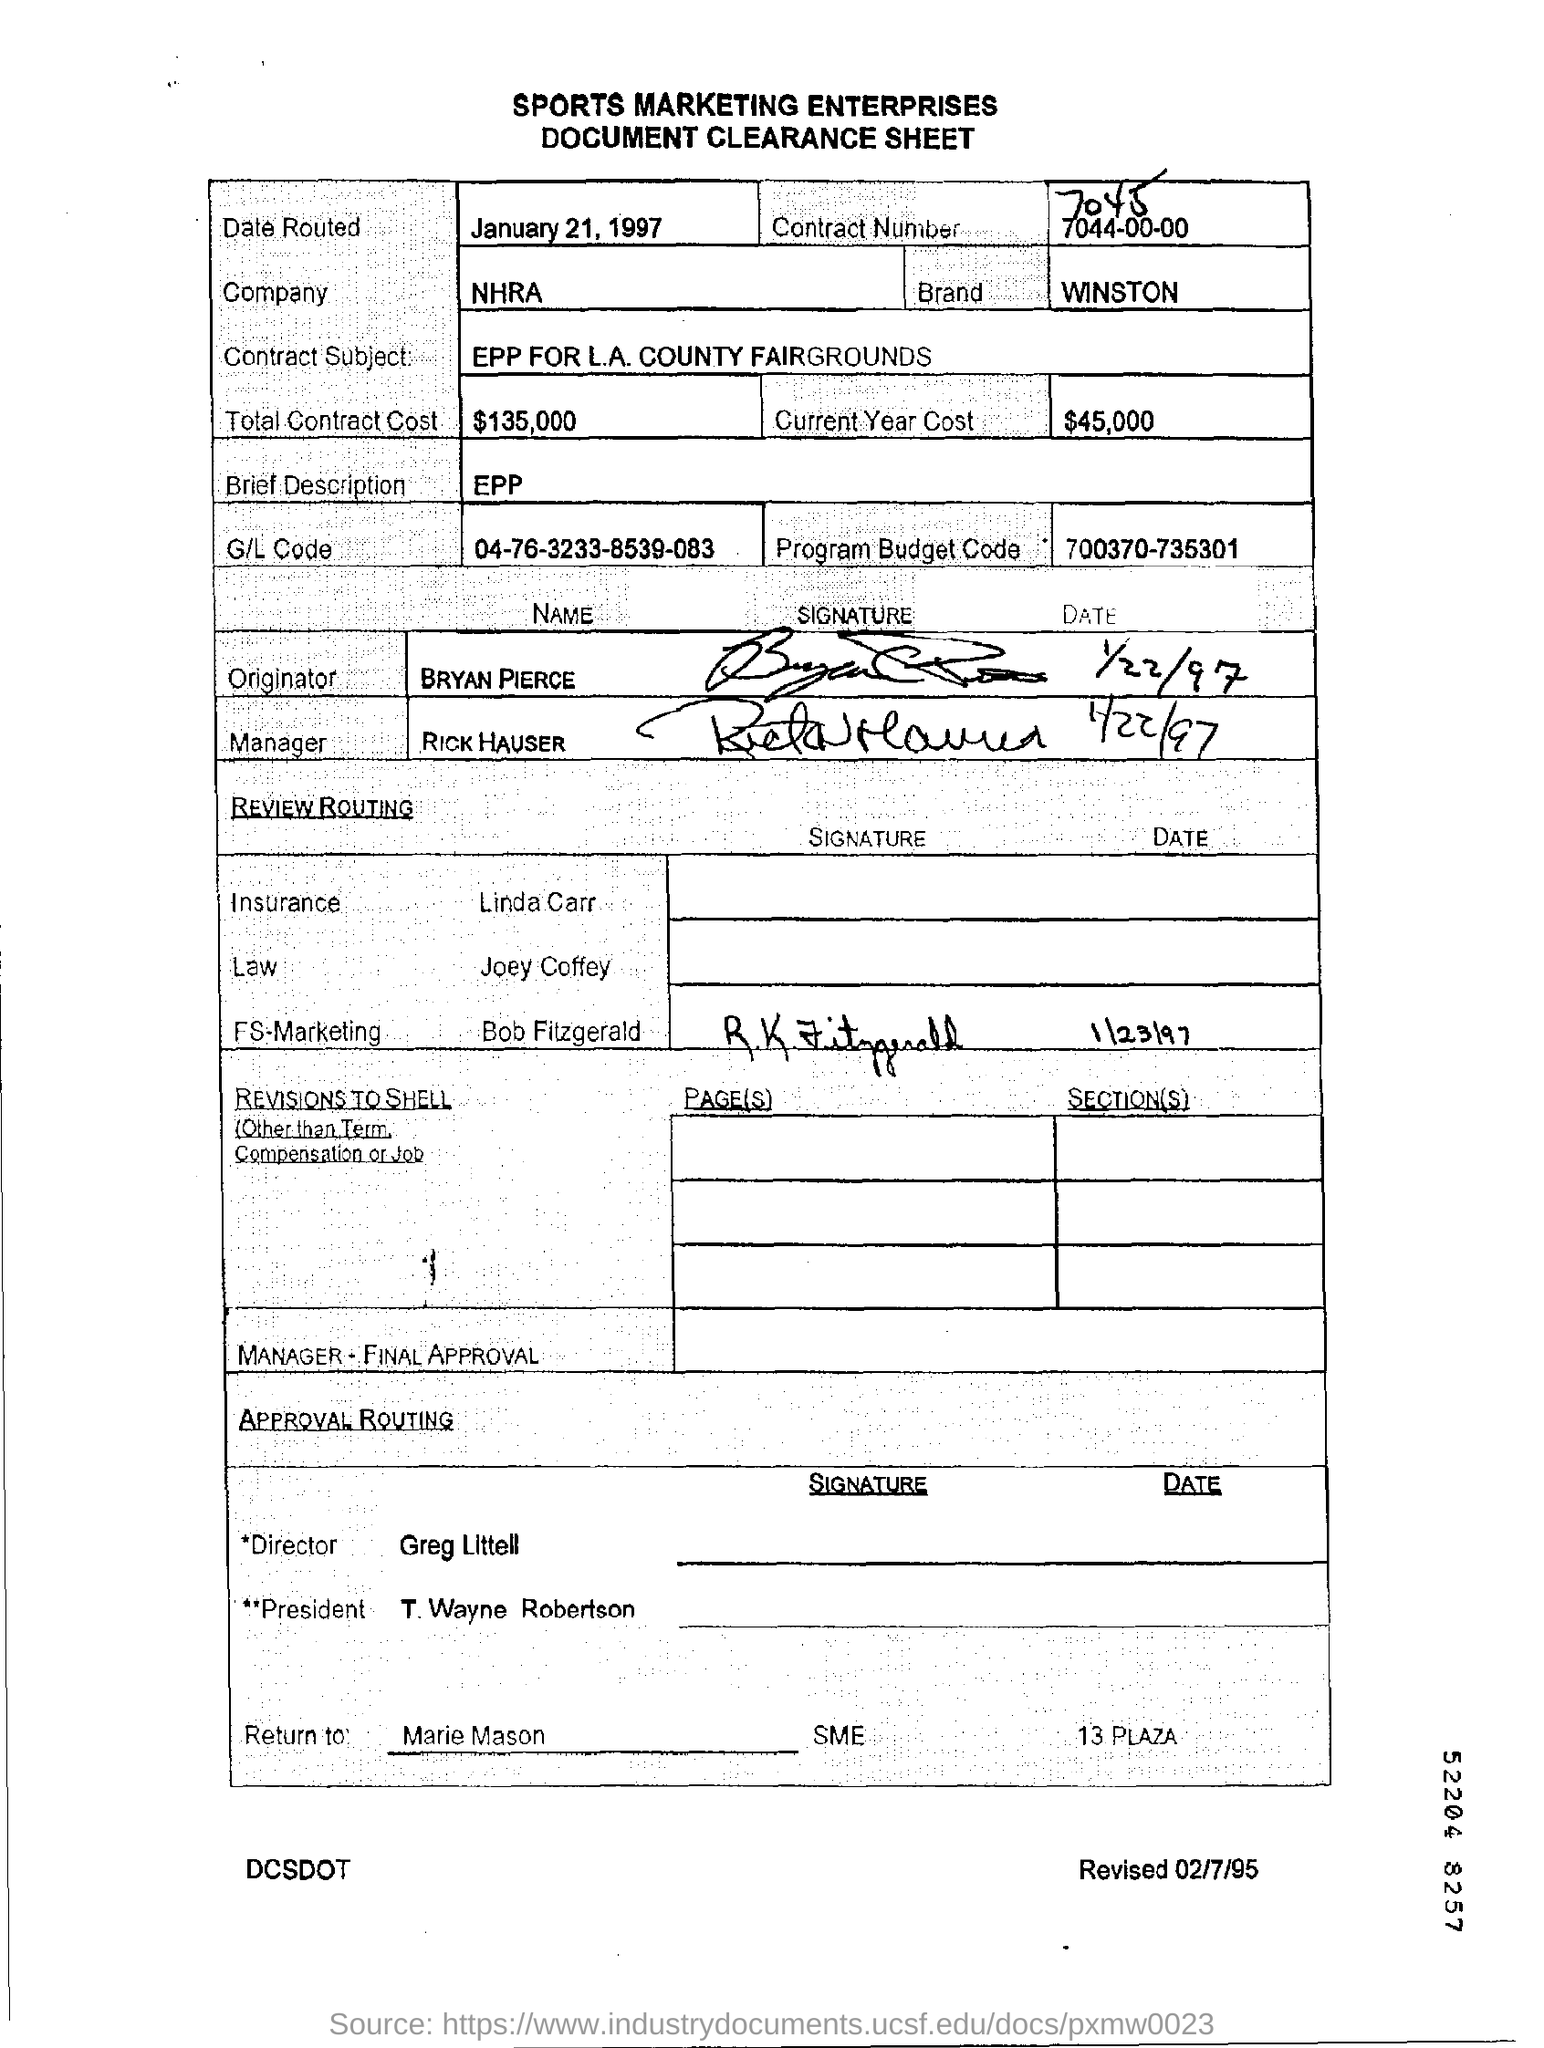What is the company name mentioned ?
Your answer should be very brief. NHRA. What is the date routed mentioned ?
Ensure brevity in your answer.  January 21, 1997. What is the brand name mentioned ?
Offer a terse response. WINSTON. What is the g/l code mentioned ?
Offer a very short reply. 04-76-3233-8539-083. What is the program budget code mentioned ?
Your response must be concise. 700370-735301. What is the current year cost mentioned ?
Your answer should be compact. $ 45,000. What is the total contract cost mentioned ?
Provide a short and direct response. $135,000. What is the contract subject mentioned ?
Give a very brief answer. Epp for l.a. county fairgrounds. What is the name of the originator mentioned ?
Keep it short and to the point. Bryan pierce. What is the name of the manager mentioned ?
Make the answer very short. Rick hauser. 